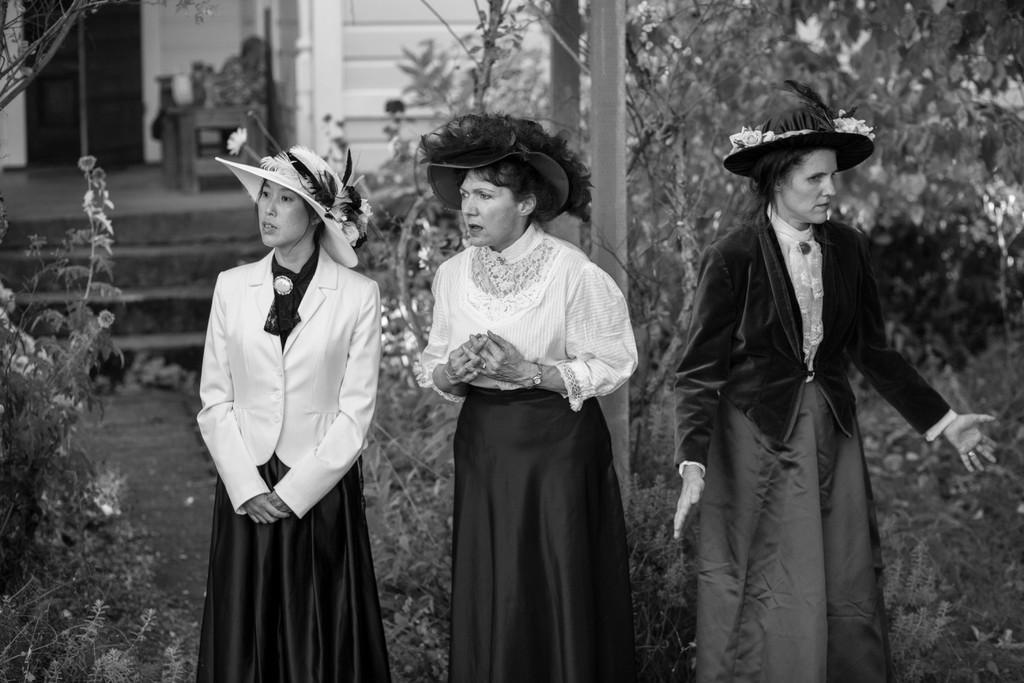What type of structure is visible in the image? There is a house in the image. What else can be seen in the image besides the house? There is an object and many plants in the image. Can you describe the plants in the image? The plants have flowers. How many people are present in the image? There are three persons in the image. What type of rice can be seen growing in the image? There is no rice present in the image; it features a house, an object, plants with flowers, and three persons. 